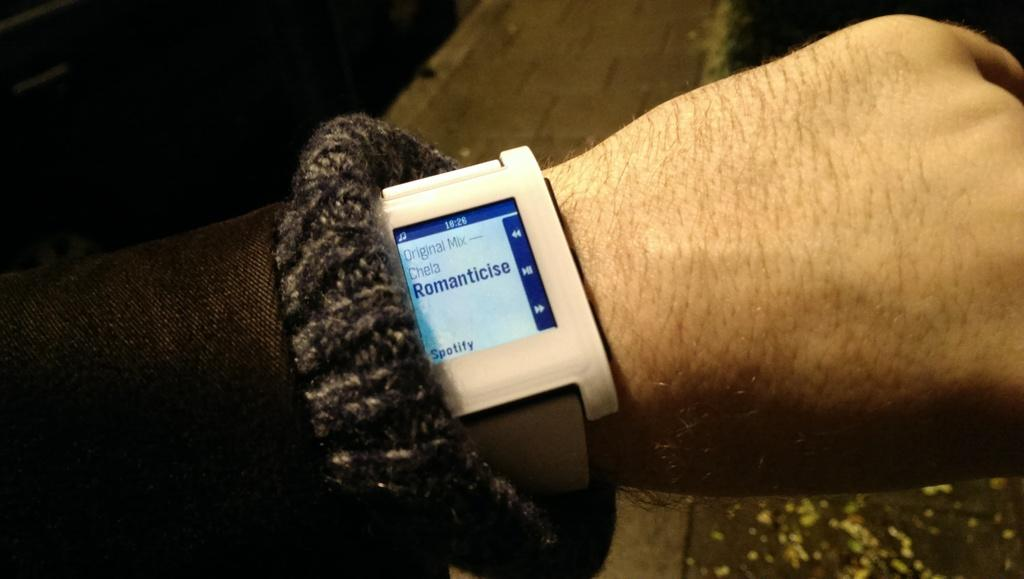<image>
Render a clear and concise summary of the photo. A watch with a screen has the word Spotify on the bottom corner. 